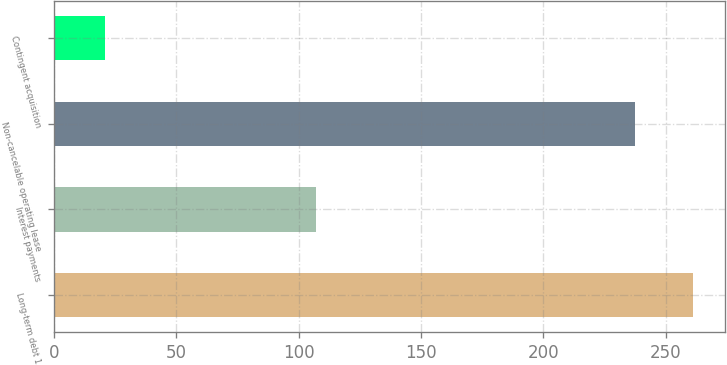Convert chart. <chart><loc_0><loc_0><loc_500><loc_500><bar_chart><fcel>Long-term debt 1<fcel>Interest payments<fcel>Non-cancelable operating lease<fcel>Contingent acquisition<nl><fcel>261.02<fcel>107.1<fcel>237.4<fcel>20.8<nl></chart> 